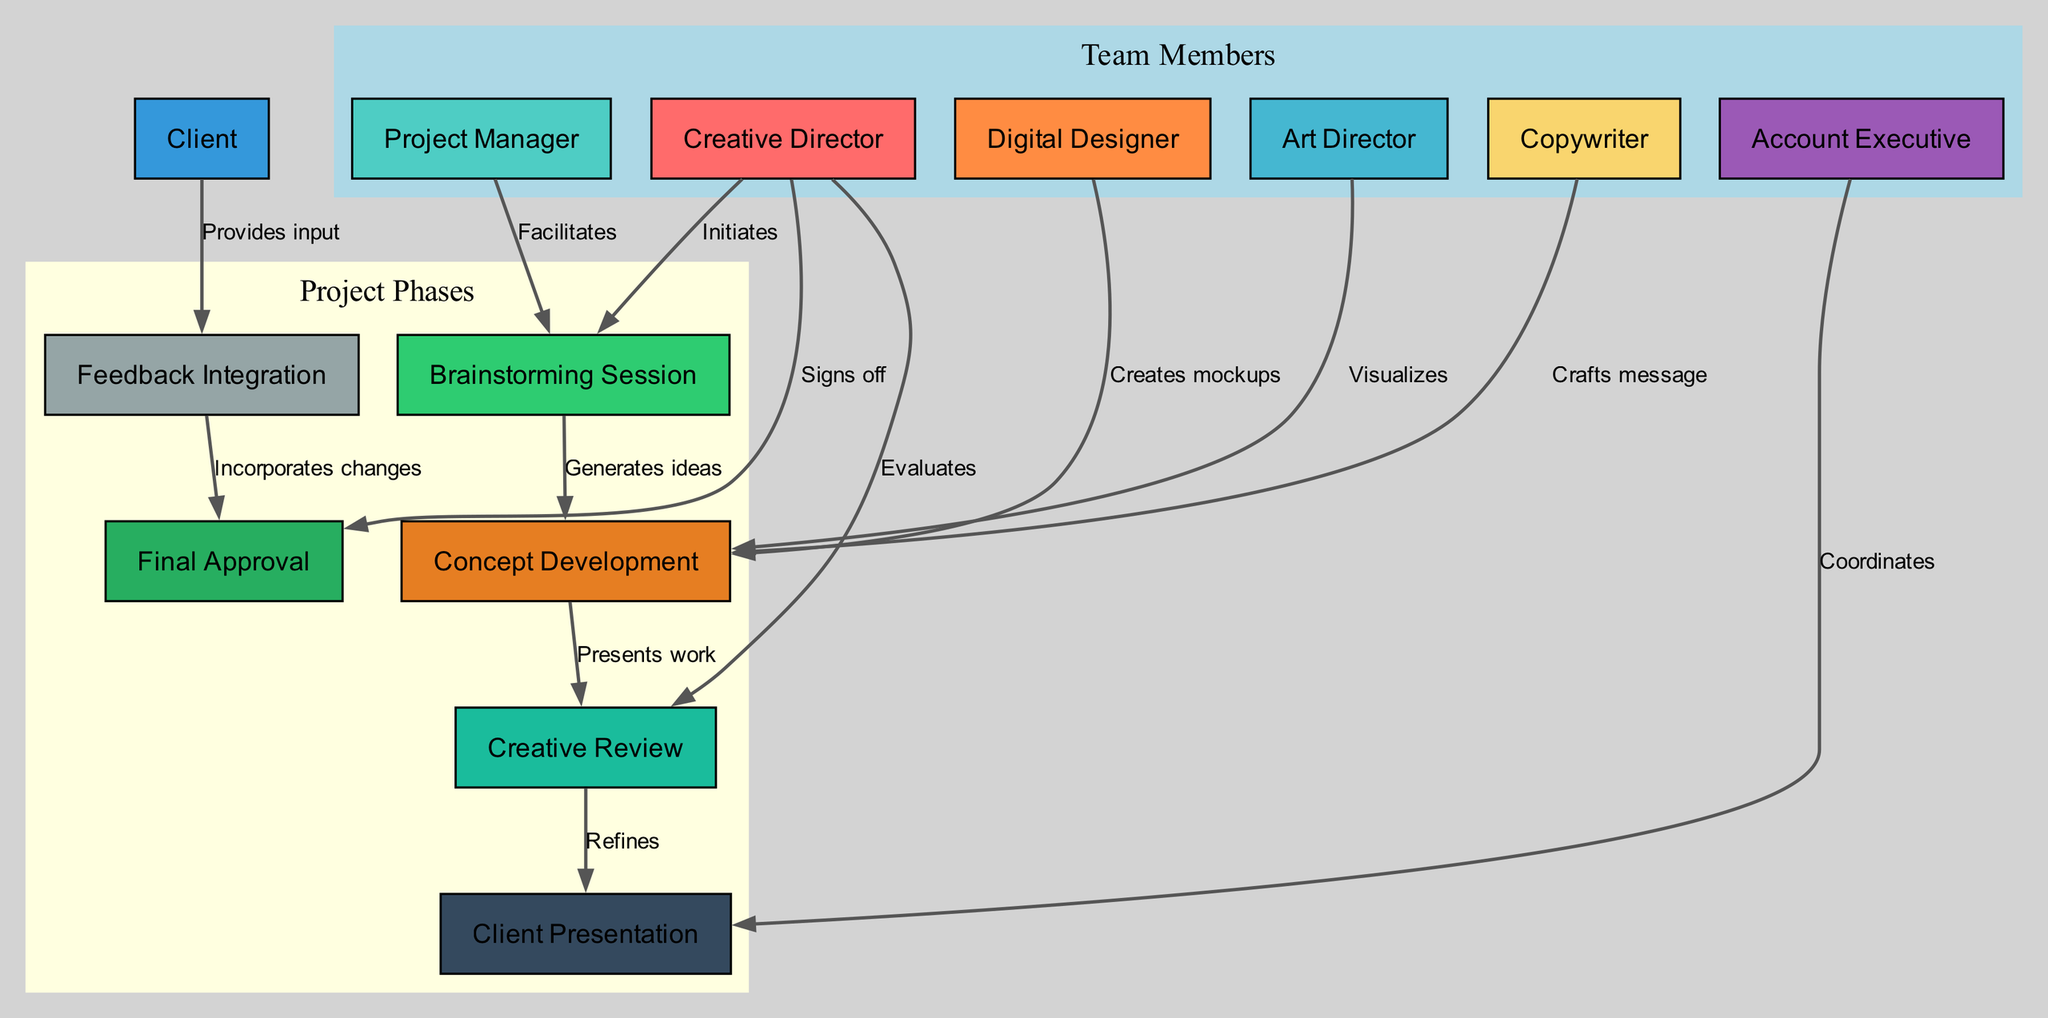What role initiates the brainstorming session? The diagram shows an edge from the "Creative Director" node to the "Brainstorming Session" node, with the label "Initiates." This indicates that the Creative Director is responsible for starting this phase of the project.
Answer: Creative Director How many total nodes are in the diagram? By counting the distinct nodes listed in the data, we find there are 13 unique nodes that represent different roles and phases in the project management structure.
Answer: 13 What are the three main project phases depicted in the diagram? The diagram groups nodes related to project phases. The relevant nodes in that context are "Brainstorming Session," "Concept Development," and "Creative Review," which outline the primary stages of the collaborative process.
Answer: Brainstorming Session, Concept Development, Creative Review Which role is connected to the final approval? Tracing the edges, the "Creative Director" node connects directly to the "Final Approval" node. This connection illustrates that the Creative Director is involved in the final sign-off process of the project.
Answer: Creative Director What action does the Account Executive take regarding the client presentation? There is a directed edge from the "Account Executive" to "Client Presentation" labeled "Coordinates." This indicates that the Account Executive plays a coordinating role in preparing for the client presentation.
Answer: Coordinates Which role provides input that leads to feedback integration? The diagram shows an arrow from the "Client" node to the "Feedback Integration" node, indicating that the Client is the source of input that influences the feedback integration process.
Answer: Client What is the relationship between Concept Development and Creative Review? The edge from "Concept Development" to "Creative Review" labeled "Presents work" indicates that the output of the concept development phase leads into the creative review phase, emphasizing the progression of the workflow.
Answer: Presents work How many edges are there that lead to the Client Presentation? By inspecting the edges defined in the data, we find there are two edges that point towards the "Client Presentation" node: one from “Creative Review” and another from “Account Executive.” Thus, there are two incoming edges to this node.
Answer: 2 What is the primary purpose of the "Feedback Integration" phase? The edge from "Feedback Integration" to "Final Approval" is labeled "Incorporates changes," signaling that the primary purpose of the feedback integration phase is to amend the project based on input received before final approval is granted.
Answer: Incorporates changes 